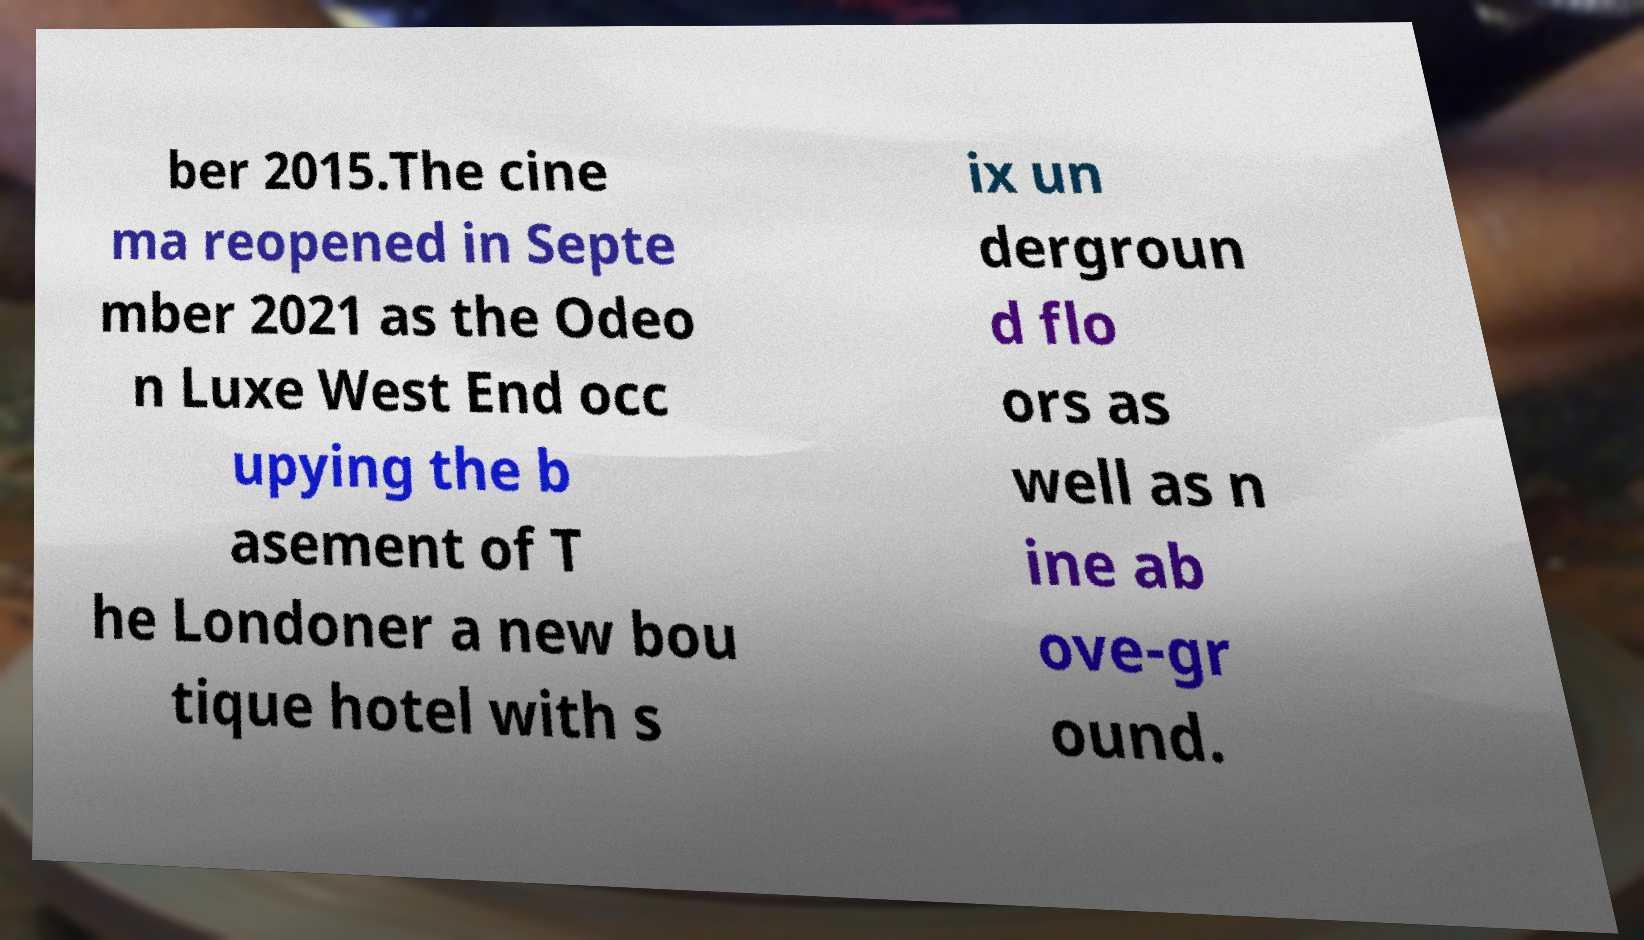Could you extract and type out the text from this image? ber 2015.The cine ma reopened in Septe mber 2021 as the Odeo n Luxe West End occ upying the b asement of T he Londoner a new bou tique hotel with s ix un dergroun d flo ors as well as n ine ab ove-gr ound. 